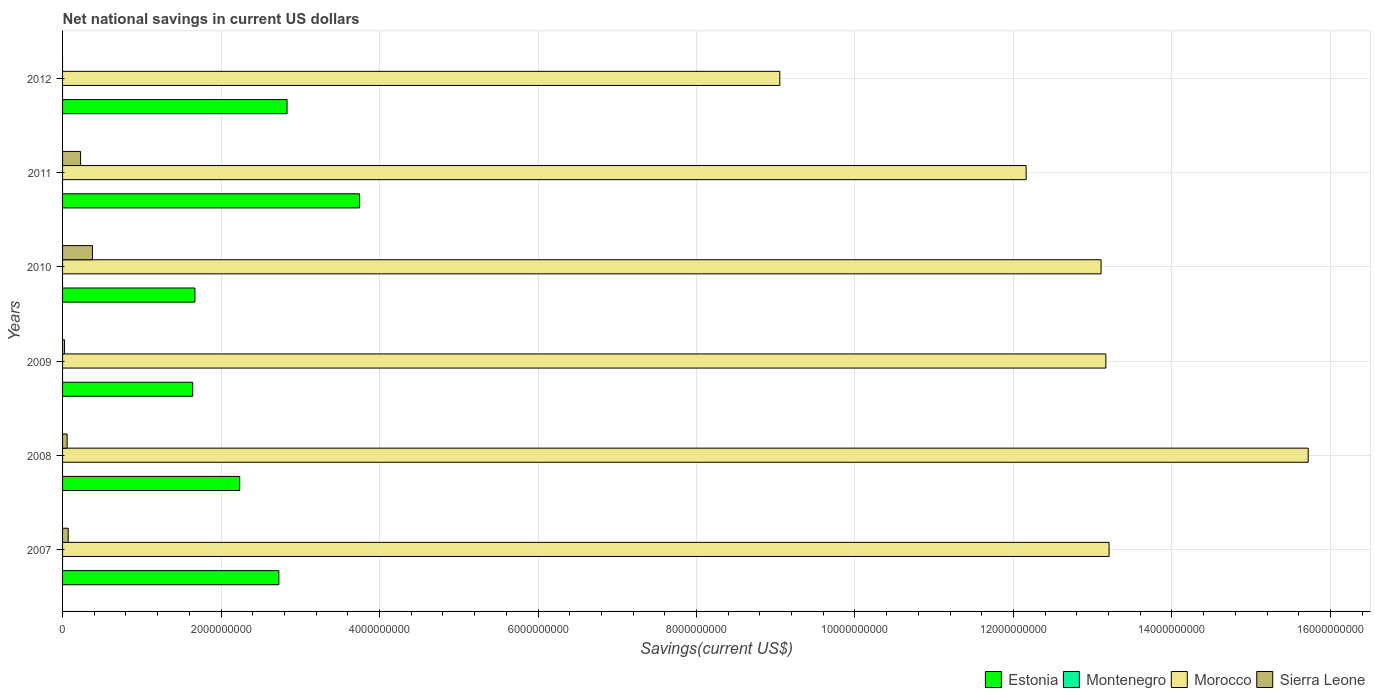How many groups of bars are there?
Offer a terse response. 6. Are the number of bars per tick equal to the number of legend labels?
Give a very brief answer. No. Are the number of bars on each tick of the Y-axis equal?
Your answer should be compact. No. How many bars are there on the 6th tick from the bottom?
Keep it short and to the point. 2. What is the label of the 5th group of bars from the top?
Offer a very short reply. 2008. What is the net national savings in Morocco in 2007?
Your response must be concise. 1.32e+1. Across all years, what is the maximum net national savings in Morocco?
Give a very brief answer. 1.57e+1. Across all years, what is the minimum net national savings in Montenegro?
Your answer should be very brief. 0. In which year was the net national savings in Sierra Leone maximum?
Your answer should be very brief. 2010. What is the total net national savings in Estonia in the graph?
Make the answer very short. 1.49e+1. What is the difference between the net national savings in Estonia in 2009 and that in 2010?
Keep it short and to the point. -2.75e+07. What is the difference between the net national savings in Montenegro in 2010 and the net national savings in Morocco in 2012?
Keep it short and to the point. -9.05e+09. What is the average net national savings in Estonia per year?
Make the answer very short. 2.48e+09. In the year 2009, what is the difference between the net national savings in Estonia and net national savings in Sierra Leone?
Offer a very short reply. 1.62e+09. What is the ratio of the net national savings in Sierra Leone in 2009 to that in 2011?
Offer a very short reply. 0.11. Is the net national savings in Estonia in 2008 less than that in 2012?
Offer a terse response. Yes. Is the difference between the net national savings in Estonia in 2010 and 2011 greater than the difference between the net national savings in Sierra Leone in 2010 and 2011?
Provide a succinct answer. No. What is the difference between the highest and the second highest net national savings in Morocco?
Offer a terse response. 2.51e+09. What is the difference between the highest and the lowest net national savings in Estonia?
Give a very brief answer. 2.11e+09. In how many years, is the net national savings in Morocco greater than the average net national savings in Morocco taken over all years?
Provide a succinct answer. 4. How many bars are there?
Make the answer very short. 17. Are all the bars in the graph horizontal?
Keep it short and to the point. Yes. Are the values on the major ticks of X-axis written in scientific E-notation?
Keep it short and to the point. No. Does the graph contain grids?
Your answer should be very brief. Yes. How many legend labels are there?
Your answer should be compact. 4. What is the title of the graph?
Your response must be concise. Net national savings in current US dollars. What is the label or title of the X-axis?
Offer a very short reply. Savings(current US$). What is the label or title of the Y-axis?
Ensure brevity in your answer.  Years. What is the Savings(current US$) in Estonia in 2007?
Ensure brevity in your answer.  2.73e+09. What is the Savings(current US$) of Morocco in 2007?
Offer a very short reply. 1.32e+1. What is the Savings(current US$) of Sierra Leone in 2007?
Keep it short and to the point. 7.09e+07. What is the Savings(current US$) in Estonia in 2008?
Your response must be concise. 2.24e+09. What is the Savings(current US$) of Morocco in 2008?
Offer a very short reply. 1.57e+1. What is the Savings(current US$) in Sierra Leone in 2008?
Keep it short and to the point. 5.80e+07. What is the Savings(current US$) in Estonia in 2009?
Make the answer very short. 1.64e+09. What is the Savings(current US$) of Montenegro in 2009?
Your answer should be compact. 0. What is the Savings(current US$) in Morocco in 2009?
Keep it short and to the point. 1.32e+1. What is the Savings(current US$) in Sierra Leone in 2009?
Make the answer very short. 2.50e+07. What is the Savings(current US$) in Estonia in 2010?
Offer a terse response. 1.67e+09. What is the Savings(current US$) of Morocco in 2010?
Your answer should be compact. 1.31e+1. What is the Savings(current US$) of Sierra Leone in 2010?
Your answer should be compact. 3.77e+08. What is the Savings(current US$) of Estonia in 2011?
Ensure brevity in your answer.  3.75e+09. What is the Savings(current US$) in Montenegro in 2011?
Ensure brevity in your answer.  0. What is the Savings(current US$) in Morocco in 2011?
Provide a succinct answer. 1.22e+1. What is the Savings(current US$) of Sierra Leone in 2011?
Offer a terse response. 2.28e+08. What is the Savings(current US$) of Estonia in 2012?
Keep it short and to the point. 2.83e+09. What is the Savings(current US$) in Montenegro in 2012?
Ensure brevity in your answer.  0. What is the Savings(current US$) in Morocco in 2012?
Ensure brevity in your answer.  9.05e+09. What is the Savings(current US$) of Sierra Leone in 2012?
Your answer should be very brief. 0. Across all years, what is the maximum Savings(current US$) of Estonia?
Make the answer very short. 3.75e+09. Across all years, what is the maximum Savings(current US$) of Morocco?
Offer a terse response. 1.57e+1. Across all years, what is the maximum Savings(current US$) of Sierra Leone?
Keep it short and to the point. 3.77e+08. Across all years, what is the minimum Savings(current US$) of Estonia?
Offer a very short reply. 1.64e+09. Across all years, what is the minimum Savings(current US$) of Morocco?
Provide a short and direct response. 9.05e+09. Across all years, what is the minimum Savings(current US$) of Sierra Leone?
Ensure brevity in your answer.  0. What is the total Savings(current US$) of Estonia in the graph?
Your response must be concise. 1.49e+1. What is the total Savings(current US$) of Montenegro in the graph?
Your answer should be very brief. 0. What is the total Savings(current US$) of Morocco in the graph?
Your answer should be compact. 7.64e+1. What is the total Savings(current US$) in Sierra Leone in the graph?
Your answer should be compact. 7.59e+08. What is the difference between the Savings(current US$) in Estonia in 2007 and that in 2008?
Make the answer very short. 4.94e+08. What is the difference between the Savings(current US$) in Morocco in 2007 and that in 2008?
Offer a very short reply. -2.51e+09. What is the difference between the Savings(current US$) in Sierra Leone in 2007 and that in 2008?
Provide a short and direct response. 1.29e+07. What is the difference between the Savings(current US$) of Estonia in 2007 and that in 2009?
Give a very brief answer. 1.09e+09. What is the difference between the Savings(current US$) of Morocco in 2007 and that in 2009?
Offer a terse response. 4.07e+07. What is the difference between the Savings(current US$) of Sierra Leone in 2007 and that in 2009?
Your response must be concise. 4.59e+07. What is the difference between the Savings(current US$) in Estonia in 2007 and that in 2010?
Your answer should be compact. 1.06e+09. What is the difference between the Savings(current US$) in Morocco in 2007 and that in 2010?
Keep it short and to the point. 1.01e+08. What is the difference between the Savings(current US$) in Sierra Leone in 2007 and that in 2010?
Your answer should be very brief. -3.06e+08. What is the difference between the Savings(current US$) of Estonia in 2007 and that in 2011?
Provide a succinct answer. -1.02e+09. What is the difference between the Savings(current US$) in Morocco in 2007 and that in 2011?
Provide a short and direct response. 1.05e+09. What is the difference between the Savings(current US$) of Sierra Leone in 2007 and that in 2011?
Keep it short and to the point. -1.57e+08. What is the difference between the Savings(current US$) of Estonia in 2007 and that in 2012?
Offer a terse response. -1.03e+08. What is the difference between the Savings(current US$) in Morocco in 2007 and that in 2012?
Provide a succinct answer. 4.16e+09. What is the difference between the Savings(current US$) of Estonia in 2008 and that in 2009?
Provide a short and direct response. 5.93e+08. What is the difference between the Savings(current US$) in Morocco in 2008 and that in 2009?
Offer a very short reply. 2.55e+09. What is the difference between the Savings(current US$) of Sierra Leone in 2008 and that in 2009?
Give a very brief answer. 3.30e+07. What is the difference between the Savings(current US$) in Estonia in 2008 and that in 2010?
Make the answer very short. 5.66e+08. What is the difference between the Savings(current US$) of Morocco in 2008 and that in 2010?
Provide a short and direct response. 2.61e+09. What is the difference between the Savings(current US$) of Sierra Leone in 2008 and that in 2010?
Give a very brief answer. -3.19e+08. What is the difference between the Savings(current US$) of Estonia in 2008 and that in 2011?
Keep it short and to the point. -1.51e+09. What is the difference between the Savings(current US$) in Morocco in 2008 and that in 2011?
Ensure brevity in your answer.  3.56e+09. What is the difference between the Savings(current US$) in Sierra Leone in 2008 and that in 2011?
Offer a terse response. -1.70e+08. What is the difference between the Savings(current US$) of Estonia in 2008 and that in 2012?
Make the answer very short. -5.97e+08. What is the difference between the Savings(current US$) of Morocco in 2008 and that in 2012?
Your response must be concise. 6.67e+09. What is the difference between the Savings(current US$) of Estonia in 2009 and that in 2010?
Your answer should be very brief. -2.75e+07. What is the difference between the Savings(current US$) in Morocco in 2009 and that in 2010?
Your answer should be compact. 6.03e+07. What is the difference between the Savings(current US$) in Sierra Leone in 2009 and that in 2010?
Your answer should be very brief. -3.52e+08. What is the difference between the Savings(current US$) in Estonia in 2009 and that in 2011?
Your answer should be compact. -2.11e+09. What is the difference between the Savings(current US$) in Morocco in 2009 and that in 2011?
Provide a succinct answer. 1.01e+09. What is the difference between the Savings(current US$) in Sierra Leone in 2009 and that in 2011?
Provide a short and direct response. -2.03e+08. What is the difference between the Savings(current US$) of Estonia in 2009 and that in 2012?
Your response must be concise. -1.19e+09. What is the difference between the Savings(current US$) in Morocco in 2009 and that in 2012?
Make the answer very short. 4.11e+09. What is the difference between the Savings(current US$) of Estonia in 2010 and that in 2011?
Provide a short and direct response. -2.08e+09. What is the difference between the Savings(current US$) in Morocco in 2010 and that in 2011?
Provide a short and direct response. 9.45e+08. What is the difference between the Savings(current US$) of Sierra Leone in 2010 and that in 2011?
Offer a very short reply. 1.50e+08. What is the difference between the Savings(current US$) in Estonia in 2010 and that in 2012?
Your response must be concise. -1.16e+09. What is the difference between the Savings(current US$) in Morocco in 2010 and that in 2012?
Offer a very short reply. 4.05e+09. What is the difference between the Savings(current US$) in Estonia in 2011 and that in 2012?
Your response must be concise. 9.15e+08. What is the difference between the Savings(current US$) of Morocco in 2011 and that in 2012?
Ensure brevity in your answer.  3.11e+09. What is the difference between the Savings(current US$) in Estonia in 2007 and the Savings(current US$) in Morocco in 2008?
Provide a succinct answer. -1.30e+1. What is the difference between the Savings(current US$) in Estonia in 2007 and the Savings(current US$) in Sierra Leone in 2008?
Provide a short and direct response. 2.67e+09. What is the difference between the Savings(current US$) of Morocco in 2007 and the Savings(current US$) of Sierra Leone in 2008?
Offer a very short reply. 1.31e+1. What is the difference between the Savings(current US$) of Estonia in 2007 and the Savings(current US$) of Morocco in 2009?
Keep it short and to the point. -1.04e+1. What is the difference between the Savings(current US$) in Estonia in 2007 and the Savings(current US$) in Sierra Leone in 2009?
Provide a short and direct response. 2.70e+09. What is the difference between the Savings(current US$) of Morocco in 2007 and the Savings(current US$) of Sierra Leone in 2009?
Give a very brief answer. 1.32e+1. What is the difference between the Savings(current US$) of Estonia in 2007 and the Savings(current US$) of Morocco in 2010?
Keep it short and to the point. -1.04e+1. What is the difference between the Savings(current US$) of Estonia in 2007 and the Savings(current US$) of Sierra Leone in 2010?
Provide a short and direct response. 2.35e+09. What is the difference between the Savings(current US$) in Morocco in 2007 and the Savings(current US$) in Sierra Leone in 2010?
Keep it short and to the point. 1.28e+1. What is the difference between the Savings(current US$) of Estonia in 2007 and the Savings(current US$) of Morocco in 2011?
Your answer should be very brief. -9.43e+09. What is the difference between the Savings(current US$) of Estonia in 2007 and the Savings(current US$) of Sierra Leone in 2011?
Ensure brevity in your answer.  2.50e+09. What is the difference between the Savings(current US$) in Morocco in 2007 and the Savings(current US$) in Sierra Leone in 2011?
Make the answer very short. 1.30e+1. What is the difference between the Savings(current US$) in Estonia in 2007 and the Savings(current US$) in Morocco in 2012?
Your answer should be compact. -6.32e+09. What is the difference between the Savings(current US$) in Estonia in 2008 and the Savings(current US$) in Morocco in 2009?
Ensure brevity in your answer.  -1.09e+1. What is the difference between the Savings(current US$) in Estonia in 2008 and the Savings(current US$) in Sierra Leone in 2009?
Make the answer very short. 2.21e+09. What is the difference between the Savings(current US$) of Morocco in 2008 and the Savings(current US$) of Sierra Leone in 2009?
Offer a very short reply. 1.57e+1. What is the difference between the Savings(current US$) of Estonia in 2008 and the Savings(current US$) of Morocco in 2010?
Offer a very short reply. -1.09e+1. What is the difference between the Savings(current US$) of Estonia in 2008 and the Savings(current US$) of Sierra Leone in 2010?
Offer a terse response. 1.86e+09. What is the difference between the Savings(current US$) in Morocco in 2008 and the Savings(current US$) in Sierra Leone in 2010?
Make the answer very short. 1.53e+1. What is the difference between the Savings(current US$) in Estonia in 2008 and the Savings(current US$) in Morocco in 2011?
Ensure brevity in your answer.  -9.92e+09. What is the difference between the Savings(current US$) in Estonia in 2008 and the Savings(current US$) in Sierra Leone in 2011?
Ensure brevity in your answer.  2.01e+09. What is the difference between the Savings(current US$) of Morocco in 2008 and the Savings(current US$) of Sierra Leone in 2011?
Ensure brevity in your answer.  1.55e+1. What is the difference between the Savings(current US$) of Estonia in 2008 and the Savings(current US$) of Morocco in 2012?
Keep it short and to the point. -6.82e+09. What is the difference between the Savings(current US$) of Estonia in 2009 and the Savings(current US$) of Morocco in 2010?
Keep it short and to the point. -1.15e+1. What is the difference between the Savings(current US$) of Estonia in 2009 and the Savings(current US$) of Sierra Leone in 2010?
Ensure brevity in your answer.  1.27e+09. What is the difference between the Savings(current US$) in Morocco in 2009 and the Savings(current US$) in Sierra Leone in 2010?
Ensure brevity in your answer.  1.28e+1. What is the difference between the Savings(current US$) in Estonia in 2009 and the Savings(current US$) in Morocco in 2011?
Offer a terse response. -1.05e+1. What is the difference between the Savings(current US$) of Estonia in 2009 and the Savings(current US$) of Sierra Leone in 2011?
Offer a very short reply. 1.42e+09. What is the difference between the Savings(current US$) of Morocco in 2009 and the Savings(current US$) of Sierra Leone in 2011?
Your answer should be compact. 1.29e+1. What is the difference between the Savings(current US$) in Estonia in 2009 and the Savings(current US$) in Morocco in 2012?
Provide a short and direct response. -7.41e+09. What is the difference between the Savings(current US$) of Estonia in 2010 and the Savings(current US$) of Morocco in 2011?
Ensure brevity in your answer.  -1.05e+1. What is the difference between the Savings(current US$) in Estonia in 2010 and the Savings(current US$) in Sierra Leone in 2011?
Provide a short and direct response. 1.44e+09. What is the difference between the Savings(current US$) in Morocco in 2010 and the Savings(current US$) in Sierra Leone in 2011?
Ensure brevity in your answer.  1.29e+1. What is the difference between the Savings(current US$) of Estonia in 2010 and the Savings(current US$) of Morocco in 2012?
Offer a terse response. -7.38e+09. What is the difference between the Savings(current US$) of Estonia in 2011 and the Savings(current US$) of Morocco in 2012?
Provide a succinct answer. -5.30e+09. What is the average Savings(current US$) in Estonia per year?
Keep it short and to the point. 2.48e+09. What is the average Savings(current US$) of Montenegro per year?
Provide a short and direct response. 0. What is the average Savings(current US$) of Morocco per year?
Provide a succinct answer. 1.27e+1. What is the average Savings(current US$) of Sierra Leone per year?
Provide a succinct answer. 1.26e+08. In the year 2007, what is the difference between the Savings(current US$) of Estonia and Savings(current US$) of Morocco?
Your answer should be compact. -1.05e+1. In the year 2007, what is the difference between the Savings(current US$) of Estonia and Savings(current US$) of Sierra Leone?
Make the answer very short. 2.66e+09. In the year 2007, what is the difference between the Savings(current US$) in Morocco and Savings(current US$) in Sierra Leone?
Make the answer very short. 1.31e+1. In the year 2008, what is the difference between the Savings(current US$) in Estonia and Savings(current US$) in Morocco?
Offer a very short reply. -1.35e+1. In the year 2008, what is the difference between the Savings(current US$) in Estonia and Savings(current US$) in Sierra Leone?
Offer a terse response. 2.18e+09. In the year 2008, what is the difference between the Savings(current US$) in Morocco and Savings(current US$) in Sierra Leone?
Provide a succinct answer. 1.57e+1. In the year 2009, what is the difference between the Savings(current US$) of Estonia and Savings(current US$) of Morocco?
Offer a terse response. -1.15e+1. In the year 2009, what is the difference between the Savings(current US$) in Estonia and Savings(current US$) in Sierra Leone?
Your answer should be very brief. 1.62e+09. In the year 2009, what is the difference between the Savings(current US$) of Morocco and Savings(current US$) of Sierra Leone?
Offer a terse response. 1.31e+1. In the year 2010, what is the difference between the Savings(current US$) in Estonia and Savings(current US$) in Morocco?
Give a very brief answer. -1.14e+1. In the year 2010, what is the difference between the Savings(current US$) in Estonia and Savings(current US$) in Sierra Leone?
Make the answer very short. 1.29e+09. In the year 2010, what is the difference between the Savings(current US$) of Morocco and Savings(current US$) of Sierra Leone?
Keep it short and to the point. 1.27e+1. In the year 2011, what is the difference between the Savings(current US$) in Estonia and Savings(current US$) in Morocco?
Offer a very short reply. -8.41e+09. In the year 2011, what is the difference between the Savings(current US$) of Estonia and Savings(current US$) of Sierra Leone?
Offer a very short reply. 3.52e+09. In the year 2011, what is the difference between the Savings(current US$) in Morocco and Savings(current US$) in Sierra Leone?
Give a very brief answer. 1.19e+1. In the year 2012, what is the difference between the Savings(current US$) in Estonia and Savings(current US$) in Morocco?
Your response must be concise. -6.22e+09. What is the ratio of the Savings(current US$) in Estonia in 2007 to that in 2008?
Provide a succinct answer. 1.22. What is the ratio of the Savings(current US$) of Morocco in 2007 to that in 2008?
Provide a short and direct response. 0.84. What is the ratio of the Savings(current US$) of Sierra Leone in 2007 to that in 2008?
Provide a short and direct response. 1.22. What is the ratio of the Savings(current US$) of Estonia in 2007 to that in 2009?
Provide a short and direct response. 1.66. What is the ratio of the Savings(current US$) of Morocco in 2007 to that in 2009?
Your answer should be very brief. 1. What is the ratio of the Savings(current US$) in Sierra Leone in 2007 to that in 2009?
Your answer should be very brief. 2.84. What is the ratio of the Savings(current US$) of Estonia in 2007 to that in 2010?
Ensure brevity in your answer.  1.63. What is the ratio of the Savings(current US$) of Morocco in 2007 to that in 2010?
Make the answer very short. 1.01. What is the ratio of the Savings(current US$) in Sierra Leone in 2007 to that in 2010?
Give a very brief answer. 0.19. What is the ratio of the Savings(current US$) of Estonia in 2007 to that in 2011?
Give a very brief answer. 0.73. What is the ratio of the Savings(current US$) of Morocco in 2007 to that in 2011?
Provide a short and direct response. 1.09. What is the ratio of the Savings(current US$) of Sierra Leone in 2007 to that in 2011?
Your answer should be very brief. 0.31. What is the ratio of the Savings(current US$) of Estonia in 2007 to that in 2012?
Provide a short and direct response. 0.96. What is the ratio of the Savings(current US$) of Morocco in 2007 to that in 2012?
Your response must be concise. 1.46. What is the ratio of the Savings(current US$) in Estonia in 2008 to that in 2009?
Your answer should be compact. 1.36. What is the ratio of the Savings(current US$) in Morocco in 2008 to that in 2009?
Provide a succinct answer. 1.19. What is the ratio of the Savings(current US$) of Sierra Leone in 2008 to that in 2009?
Keep it short and to the point. 2.32. What is the ratio of the Savings(current US$) of Estonia in 2008 to that in 2010?
Provide a succinct answer. 1.34. What is the ratio of the Savings(current US$) in Morocco in 2008 to that in 2010?
Provide a succinct answer. 1.2. What is the ratio of the Savings(current US$) in Sierra Leone in 2008 to that in 2010?
Keep it short and to the point. 0.15. What is the ratio of the Savings(current US$) in Estonia in 2008 to that in 2011?
Offer a very short reply. 0.6. What is the ratio of the Savings(current US$) of Morocco in 2008 to that in 2011?
Offer a terse response. 1.29. What is the ratio of the Savings(current US$) in Sierra Leone in 2008 to that in 2011?
Give a very brief answer. 0.25. What is the ratio of the Savings(current US$) of Estonia in 2008 to that in 2012?
Provide a short and direct response. 0.79. What is the ratio of the Savings(current US$) of Morocco in 2008 to that in 2012?
Provide a short and direct response. 1.74. What is the ratio of the Savings(current US$) in Estonia in 2009 to that in 2010?
Offer a very short reply. 0.98. What is the ratio of the Savings(current US$) in Sierra Leone in 2009 to that in 2010?
Provide a short and direct response. 0.07. What is the ratio of the Savings(current US$) of Estonia in 2009 to that in 2011?
Give a very brief answer. 0.44. What is the ratio of the Savings(current US$) in Morocco in 2009 to that in 2011?
Your answer should be compact. 1.08. What is the ratio of the Savings(current US$) in Sierra Leone in 2009 to that in 2011?
Provide a succinct answer. 0.11. What is the ratio of the Savings(current US$) of Estonia in 2009 to that in 2012?
Keep it short and to the point. 0.58. What is the ratio of the Savings(current US$) of Morocco in 2009 to that in 2012?
Offer a very short reply. 1.45. What is the ratio of the Savings(current US$) of Estonia in 2010 to that in 2011?
Keep it short and to the point. 0.45. What is the ratio of the Savings(current US$) in Morocco in 2010 to that in 2011?
Offer a terse response. 1.08. What is the ratio of the Savings(current US$) of Sierra Leone in 2010 to that in 2011?
Provide a succinct answer. 1.66. What is the ratio of the Savings(current US$) in Estonia in 2010 to that in 2012?
Make the answer very short. 0.59. What is the ratio of the Savings(current US$) in Morocco in 2010 to that in 2012?
Keep it short and to the point. 1.45. What is the ratio of the Savings(current US$) in Estonia in 2011 to that in 2012?
Your answer should be very brief. 1.32. What is the ratio of the Savings(current US$) in Morocco in 2011 to that in 2012?
Ensure brevity in your answer.  1.34. What is the difference between the highest and the second highest Savings(current US$) of Estonia?
Offer a very short reply. 9.15e+08. What is the difference between the highest and the second highest Savings(current US$) in Morocco?
Offer a terse response. 2.51e+09. What is the difference between the highest and the second highest Savings(current US$) of Sierra Leone?
Give a very brief answer. 1.50e+08. What is the difference between the highest and the lowest Savings(current US$) in Estonia?
Make the answer very short. 2.11e+09. What is the difference between the highest and the lowest Savings(current US$) of Morocco?
Offer a very short reply. 6.67e+09. What is the difference between the highest and the lowest Savings(current US$) of Sierra Leone?
Provide a short and direct response. 3.77e+08. 